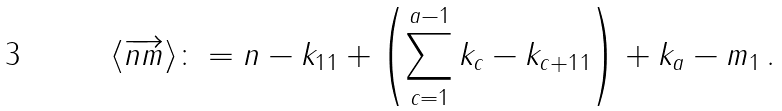<formula> <loc_0><loc_0><loc_500><loc_500>\langle \overrightarrow { n m } \rangle \colon = \| n - k _ { 1 } \| _ { 1 } + \left ( \sum _ { c = 1 } ^ { a - 1 } \| k _ { c } - k _ { c + 1 } \| _ { 1 } \right ) + \| k _ { a } - m \| _ { 1 } \, .</formula> 